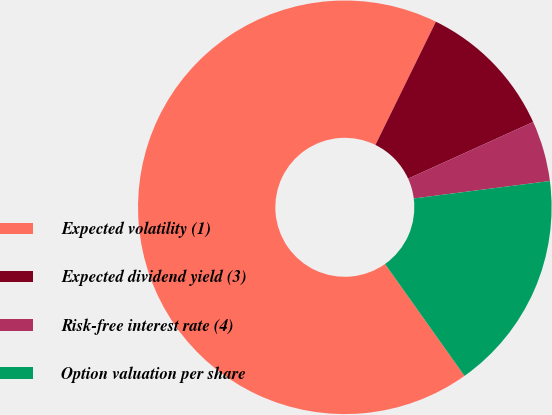<chart> <loc_0><loc_0><loc_500><loc_500><pie_chart><fcel>Expected volatility (1)<fcel>Expected dividend yield (3)<fcel>Risk-free interest rate (4)<fcel>Option valuation per share<nl><fcel>67.08%<fcel>10.97%<fcel>4.74%<fcel>17.2%<nl></chart> 